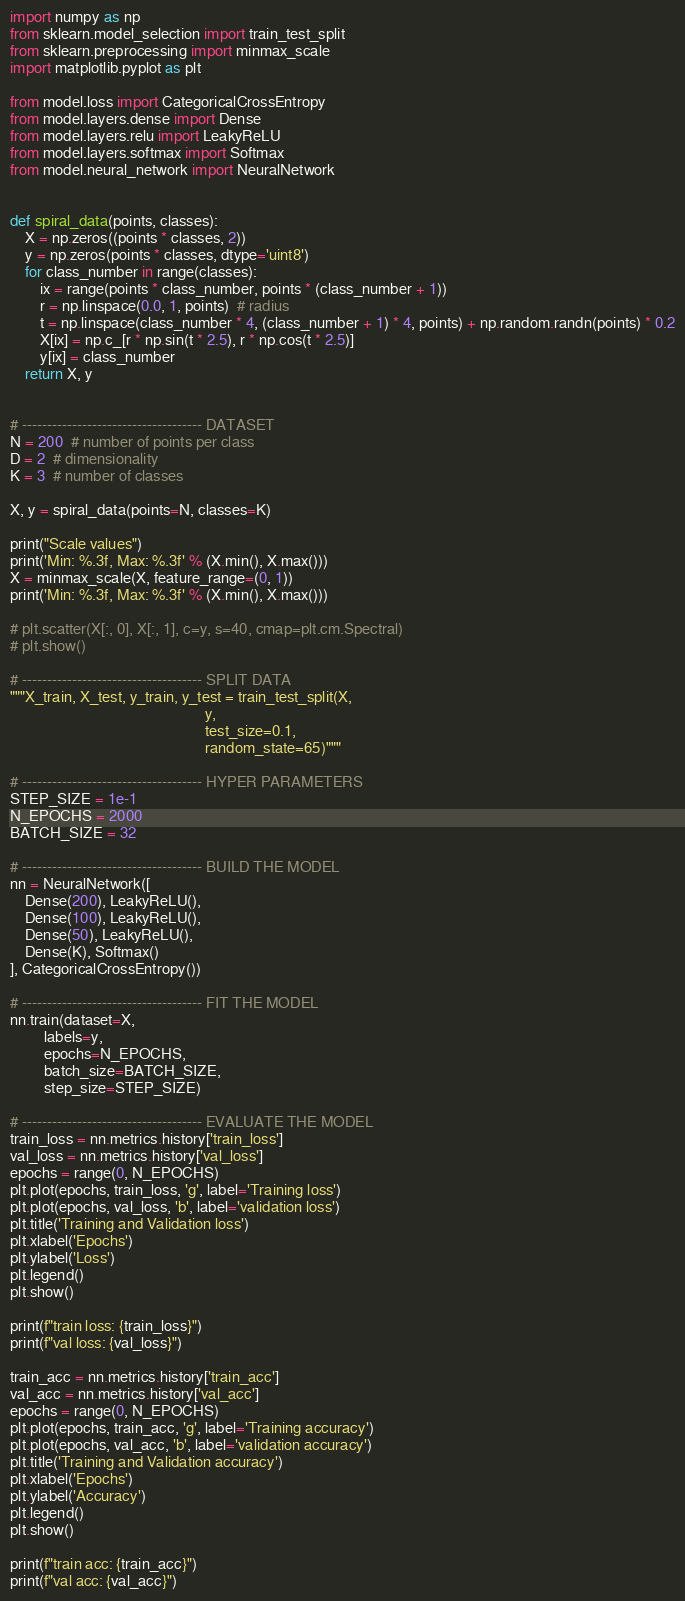<code> <loc_0><loc_0><loc_500><loc_500><_Python_>import numpy as np
from sklearn.model_selection import train_test_split
from sklearn.preprocessing import minmax_scale
import matplotlib.pyplot as plt

from model.loss import CategoricalCrossEntropy
from model.layers.dense import Dense
from model.layers.relu import LeakyReLU
from model.layers.softmax import Softmax
from model.neural_network import NeuralNetwork


def spiral_data(points, classes):
    X = np.zeros((points * classes, 2))
    y = np.zeros(points * classes, dtype='uint8')
    for class_number in range(classes):
        ix = range(points * class_number, points * (class_number + 1))
        r = np.linspace(0.0, 1, points)  # radius
        t = np.linspace(class_number * 4, (class_number + 1) * 4, points) + np.random.randn(points) * 0.2
        X[ix] = np.c_[r * np.sin(t * 2.5), r * np.cos(t * 2.5)]
        y[ix] = class_number
    return X, y


# ------------------------------------ DATASET
N = 200  # number of points per class
D = 2  # dimensionality
K = 3  # number of classes

X, y = spiral_data(points=N, classes=K)

print("Scale values")
print('Min: %.3f, Max: %.3f' % (X.min(), X.max()))
X = minmax_scale(X, feature_range=(0, 1))
print('Min: %.3f, Max: %.3f' % (X.min(), X.max()))

# plt.scatter(X[:, 0], X[:, 1], c=y, s=40, cmap=plt.cm.Spectral)
# plt.show()

# ------------------------------------ SPLIT DATA
"""X_train, X_test, y_train, y_test = train_test_split(X,
                                                    y,
                                                    test_size=0.1,
                                                    random_state=65)"""

# ------------------------------------ HYPER PARAMETERS
STEP_SIZE = 1e-1
N_EPOCHS = 2000
BATCH_SIZE = 32

# ------------------------------------ BUILD THE MODEL
nn = NeuralNetwork([
    Dense(200), LeakyReLU(),
    Dense(100), LeakyReLU(),
    Dense(50), LeakyReLU(),
    Dense(K), Softmax()
], CategoricalCrossEntropy())

# ------------------------------------ FIT THE MODEL
nn.train(dataset=X,
         labels=y,
         epochs=N_EPOCHS,
         batch_size=BATCH_SIZE,
         step_size=STEP_SIZE)

# ------------------------------------ EVALUATE THE MODEL
train_loss = nn.metrics.history['train_loss']
val_loss = nn.metrics.history['val_loss']
epochs = range(0, N_EPOCHS)
plt.plot(epochs, train_loss, 'g', label='Training loss')
plt.plot(epochs, val_loss, 'b', label='validation loss')
plt.title('Training and Validation loss')
plt.xlabel('Epochs')
plt.ylabel('Loss')
plt.legend()
plt.show()

print(f"train loss: {train_loss}")
print(f"val loss: {val_loss}")

train_acc = nn.metrics.history['train_acc']
val_acc = nn.metrics.history['val_acc']
epochs = range(0, N_EPOCHS)
plt.plot(epochs, train_acc, 'g', label='Training accuracy')
plt.plot(epochs, val_acc, 'b', label='validation accuracy')
plt.title('Training and Validation accuracy')
plt.xlabel('Epochs')
plt.ylabel('Accuracy')
plt.legend()
plt.show()

print(f"train acc: {train_acc}")
print(f"val acc: {val_acc}")
</code> 